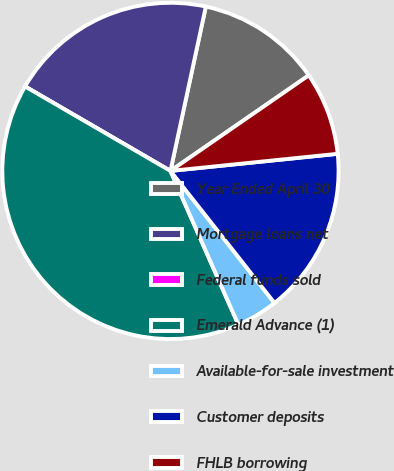Convert chart. <chart><loc_0><loc_0><loc_500><loc_500><pie_chart><fcel>Year Ended April 30<fcel>Mortgage loans net<fcel>Federal funds sold<fcel>Emerald Advance (1)<fcel>Available-for-sale investment<fcel>Customer deposits<fcel>FHLB borrowing<nl><fcel>12.0%<fcel>20.0%<fcel>0.0%<fcel>39.99%<fcel>4.0%<fcel>16.0%<fcel>8.0%<nl></chart> 